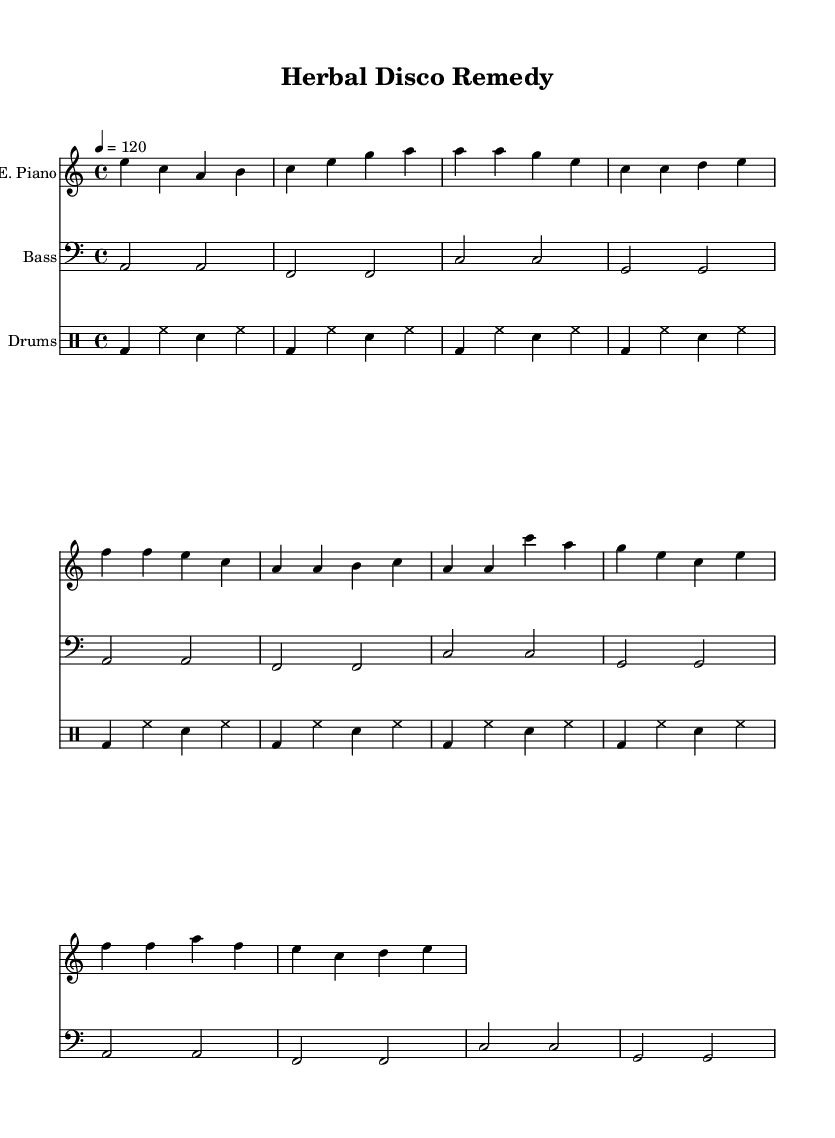What is the key signature of this music? The key signature has one flat, indicating A minor. The sheet lists "a" as the key, and since it’s in a minor key, it corresponds to its relative major, which is C major.
Answer: A minor What is the time signature of this piece? The time signature is indicated at the beginning of the score as 4/4. This means there are four beats in each measure, and a quarter note receives one beat.
Answer: 4/4 What is the tempo marking for this piece? The tempo is indicated as 120 beats per minute with the marking "4 = 120." This means the quarter note is to be played at a speed of 120 beats per minute.
Answer: 120 How many measures are in the verse section? The verse section includes eight measures, as counted from the notation provided. By analyzing the grouping of notes, it can be observed there are two phrases each containing four measures.
Answer: 8 What instrument plays the electric piano part? The electric piano part is labeled at the beginning of the staff as "E. Piano." This indicates the function of the instrument within the score.
Answer: E. Piano How many times is the bass line repeated? The bass line is specified to be repeated three times, as indicated by the expression "repeat" in the sheet music. This tells us how many times to play that section.
Answer: 3 What type of drum pattern is used in this track? The track employs a basic disco drum pattern, characterized by a repeated kick drum and hi-hat interaction commonly found in disco music.
Answer: Basic disco 